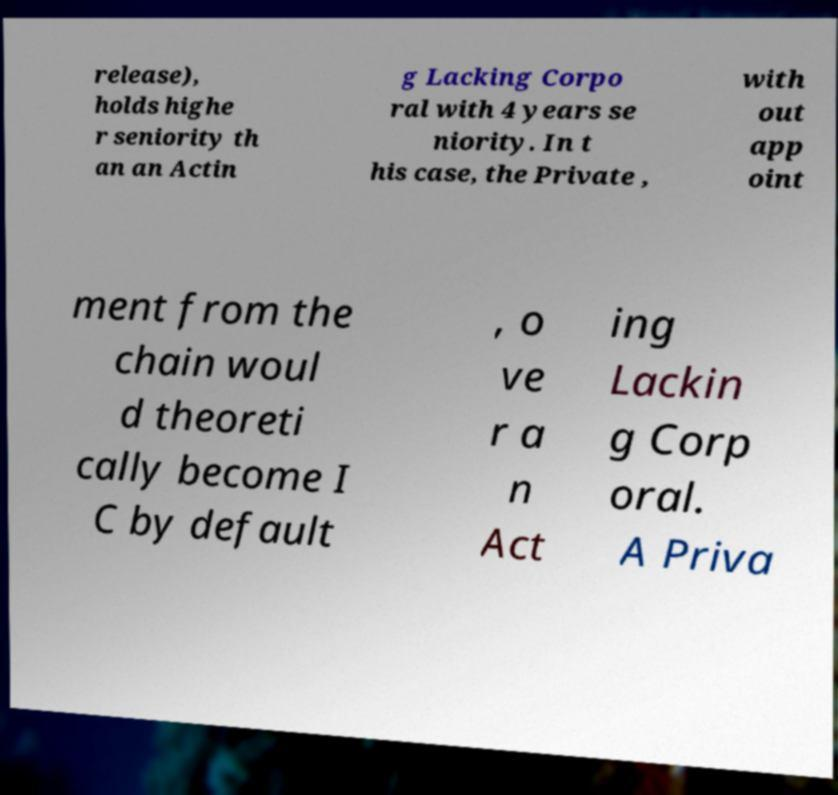There's text embedded in this image that I need extracted. Can you transcribe it verbatim? release), holds highe r seniority th an an Actin g Lacking Corpo ral with 4 years se niority. In t his case, the Private , with out app oint ment from the chain woul d theoreti cally become I C by default , o ve r a n Act ing Lackin g Corp oral. A Priva 